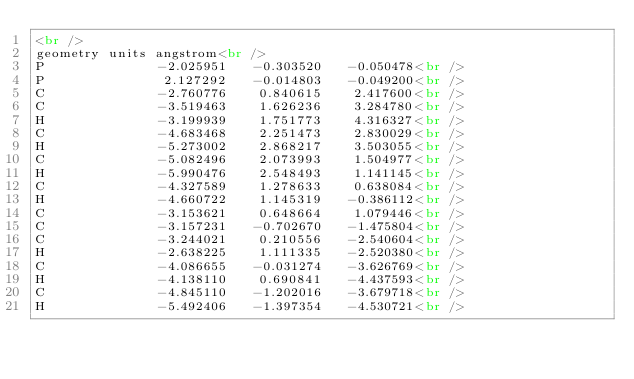Convert code to text. <code><loc_0><loc_0><loc_500><loc_500><_HTML_><br />
geometry units angstrom<br />
P              -2.025951   -0.303520   -0.050478<br />
P               2.127292   -0.014803   -0.049200<br />
C              -2.760776    0.840615    2.417600<br />
C              -3.519463    1.626236    3.284780<br />
H              -3.199939    1.751773    4.316327<br />
C              -4.683468    2.251473    2.830029<br />
H              -5.273002    2.868217    3.503055<br />
C              -5.082496    2.073993    1.504977<br />
H              -5.990476    2.548493    1.141145<br />
C              -4.327589    1.278633    0.638084<br />
H              -4.660722    1.145319   -0.386112<br />
C              -3.153621    0.648664    1.079446<br />
C              -3.157231   -0.702670   -1.475804<br />
C              -3.244021    0.210556   -2.540604<br />
H              -2.638225    1.111335   -2.520380<br />
C              -4.086655   -0.031274   -3.626769<br />
H              -4.138110    0.690841   -4.437593<br />
C              -4.845110   -1.202016   -3.679718<br />
H              -5.492406   -1.397354   -4.530721<br /></code> 